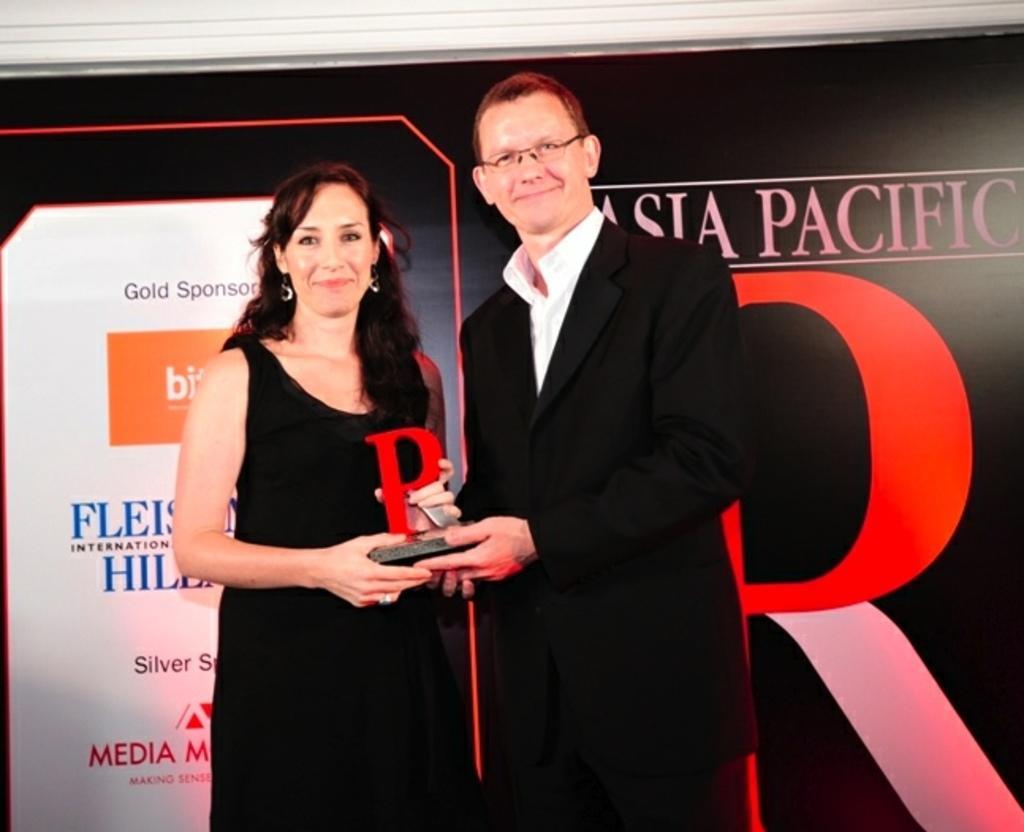Please provide a concise description of this image. In the image to the left side there is a lady with black dress is stunning. Beside him there is a man with black jacket and white shirt is standing. Both the lady and the man is holding the award in their hands. Behind them there is a poster. 